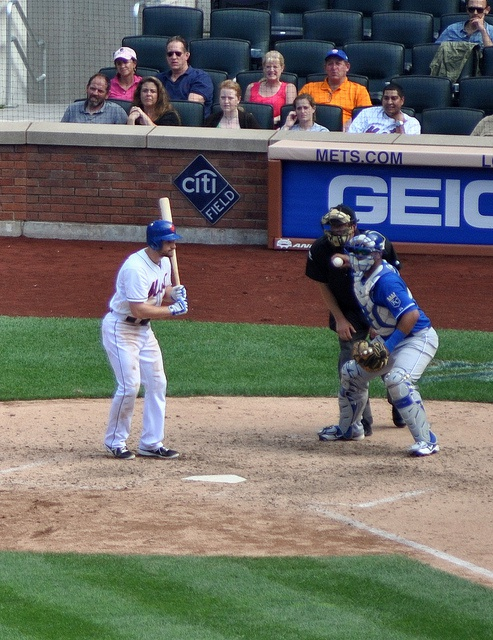Describe the objects in this image and their specific colors. I can see people in lightgray, gray, darkgray, black, and navy tones, people in lightgray, lavender, and darkgray tones, chair in lightgray, black, navy, blue, and gray tones, people in lightgray, black, gray, maroon, and navy tones, and people in lightgray, orange, red, brown, and black tones in this image. 